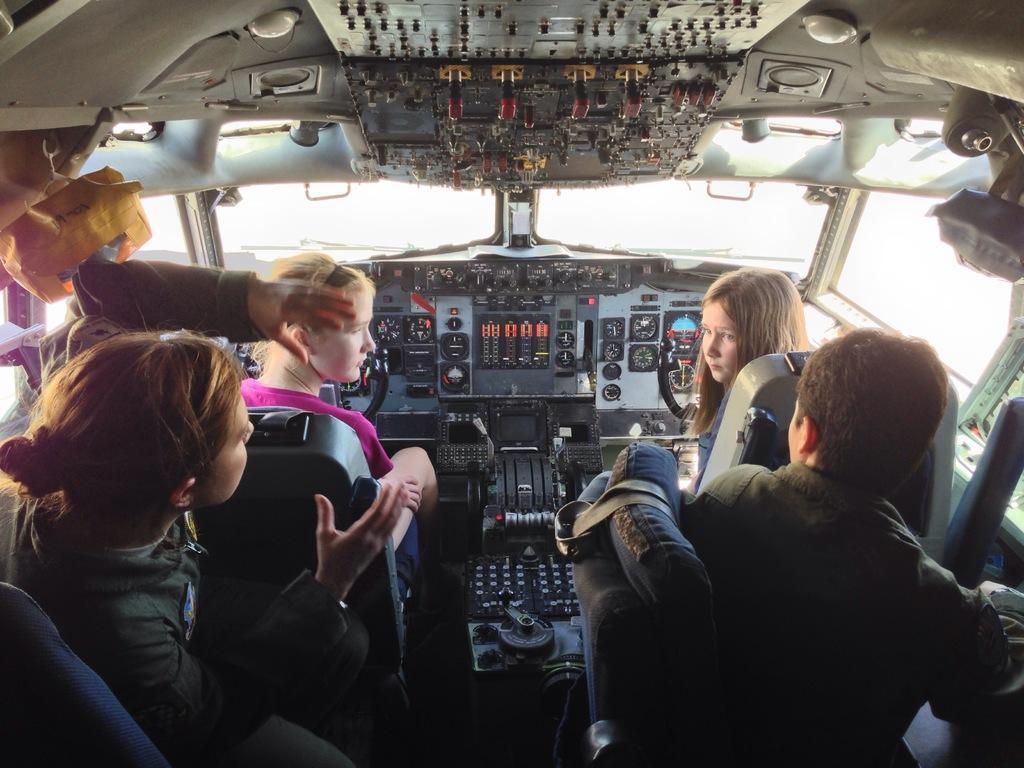Describe this image in one or two sentences. In the image there is a inside of the flight. To the front of the image there are two persons sitting on the seats. In front of them there are two persons sitting on the seats. In front of them there are switch boards, screens and some other items. And to the top of the image there is a switch board with switches. And in front of the persons there is a window with the glass and also there are few other items in it. 